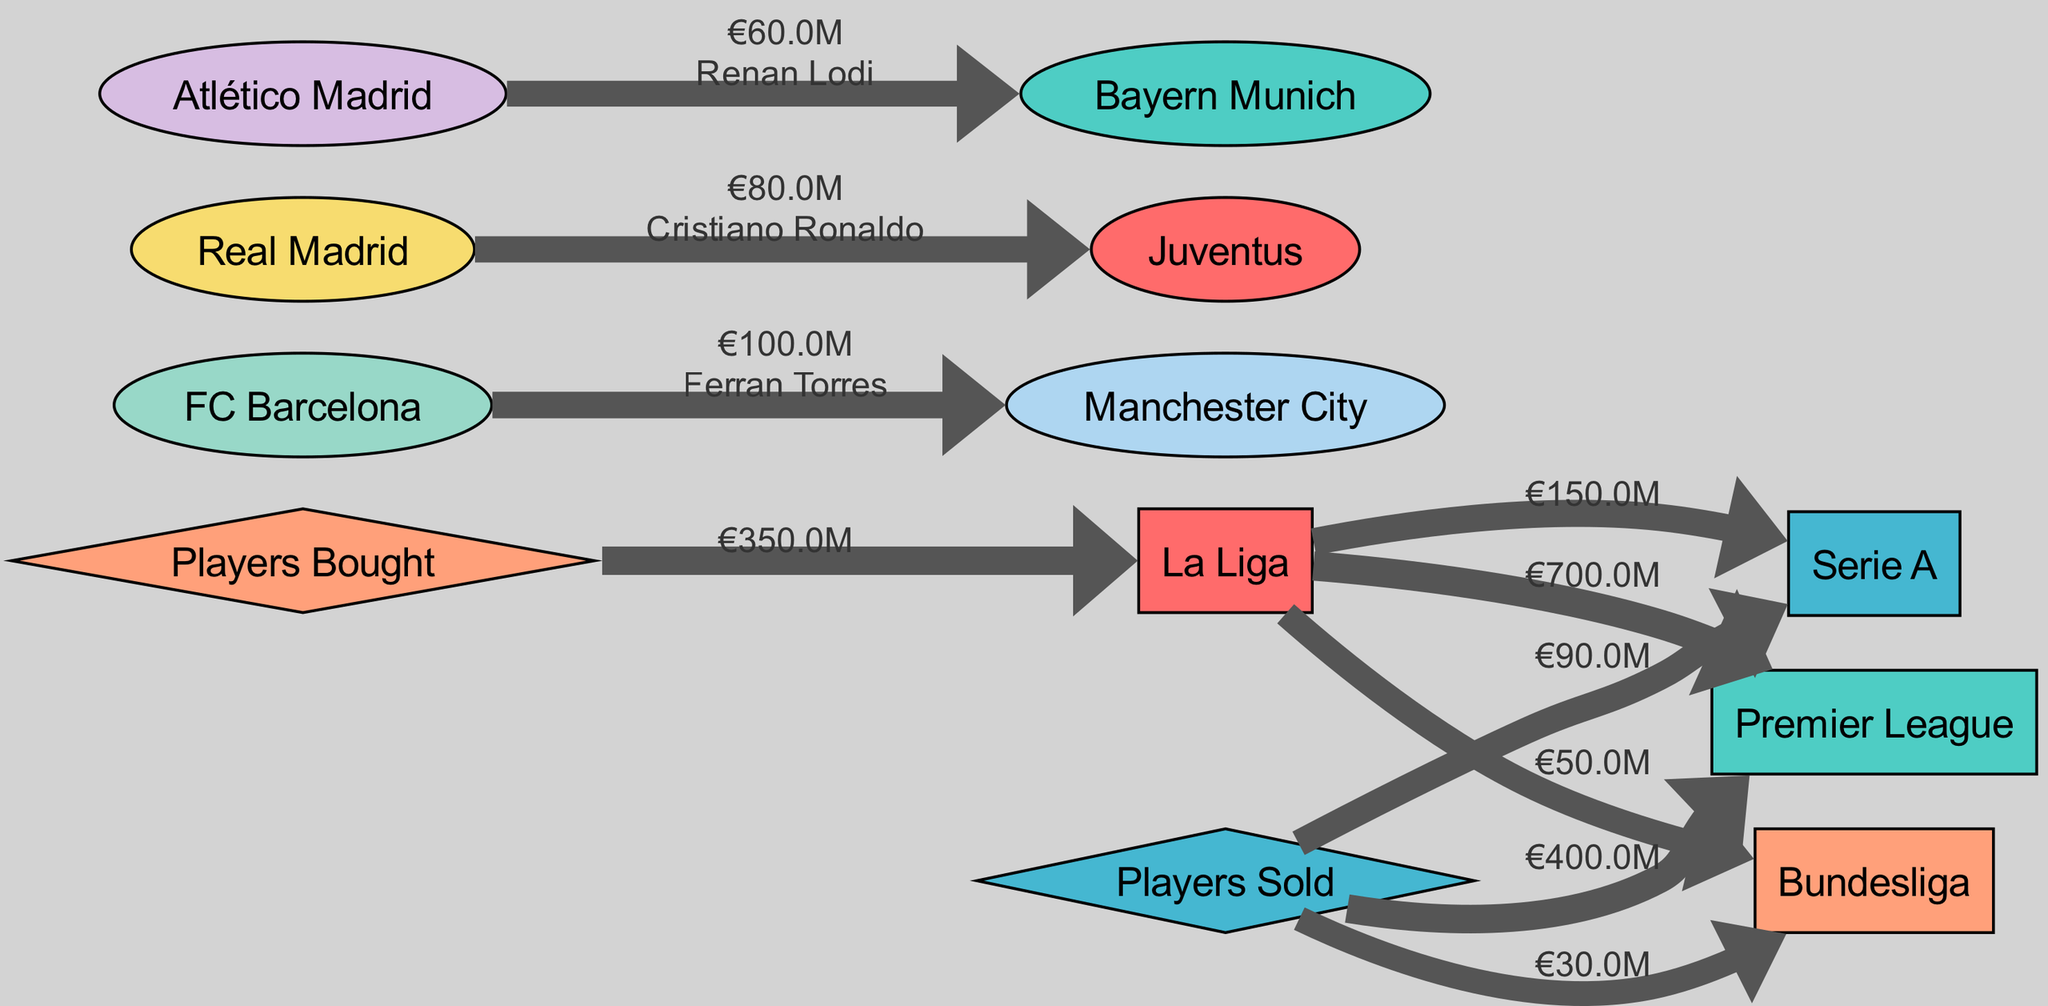What is the total outflow of funds from La Liga to the Premier League? The diagram shows a direct link from La Liga to the Premier League with a value of €700 million. Thus, this amount represents the total outflow of funds from La Liga to the Premier League.
Answer: €700 million How many players were sold from La Liga to Serie A? The diagram indicates a monetary flow of €150 million from La Liga to Serie A, but there are no specific player counts mentioned. Therefore, the number of players sold cannot be determined just from the diagram.
Answer: Unknown What value did Atlético Madrid receive for Renan Lodi? The diagram shows a link from Atlético Madrid to Bayern Munich with a value of €60 million, indicating the amount Atlético Madrid received for Renan Lodi.
Answer: €60 million How much money did La Liga clubs spend on buying players? According to the diagram, the total value of players bought by La Liga from other leagues is €350 million. This is indicated by the flow from the "Players Bought" node to La Liga.
Answer: €350 million Which league received the highest total outflow of funds from La Liga? By comparing the flows, the Premier League has a total outflow amount of €700 million, which is higher than the other leagues (Serie A: €150 million, Bundesliga: €50 million). Thus, the Premier League received the highest outflow.
Answer: Premier League How many total transfers of players from La Liga to other leagues were recorded? The total number of distinct transfers can be inferred from the different links shown in the diagram. There are three distinct league links indicated (Premier League, Serie A, Bundesliga) plus individual transfers noted. This results in several individual transfers going to each league. An exact count would require detailed player data, which is not provided.
Answer: Unknown What is the total amount of funds flowing out of La Liga to other leagues combined? By adding the respective values from La Liga to each receiving league: €700 million (Premier League) + €150 million (Serie A) + €50 million (Bundesliga) equals a total of €900 million. Therefore, this is the total outflow of funds combined from La Liga.
Answer: €900 million How much did La Liga clubs receive in total from player sales? The diagram shows the total amount sold to each league, specifically €400 million to the Premier League, €90 million to Serie A, and €30 million to Bundesliga. Adding these amounts gives a total of €520 million received from player sales.
Answer: €520 million 